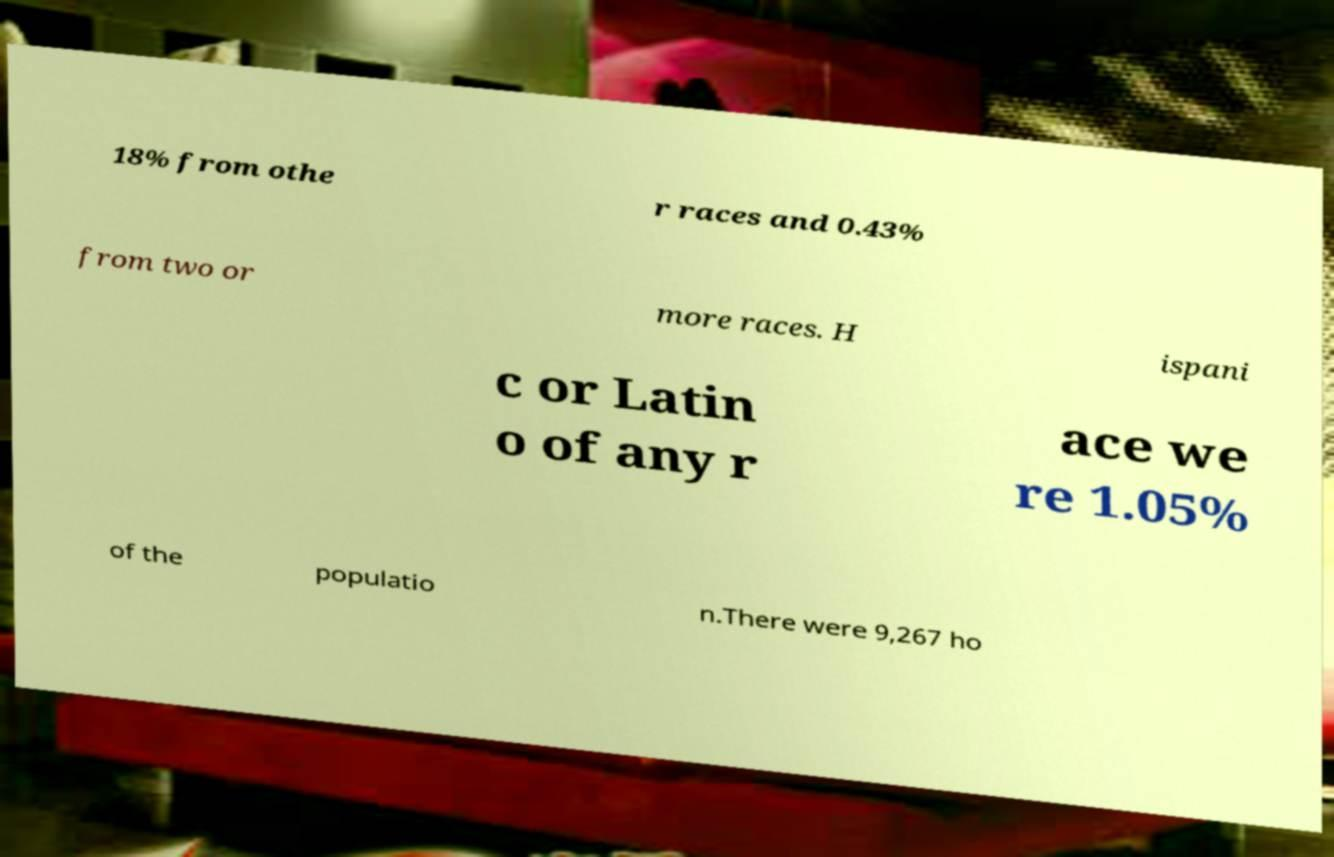Could you extract and type out the text from this image? 18% from othe r races and 0.43% from two or more races. H ispani c or Latin o of any r ace we re 1.05% of the populatio n.There were 9,267 ho 